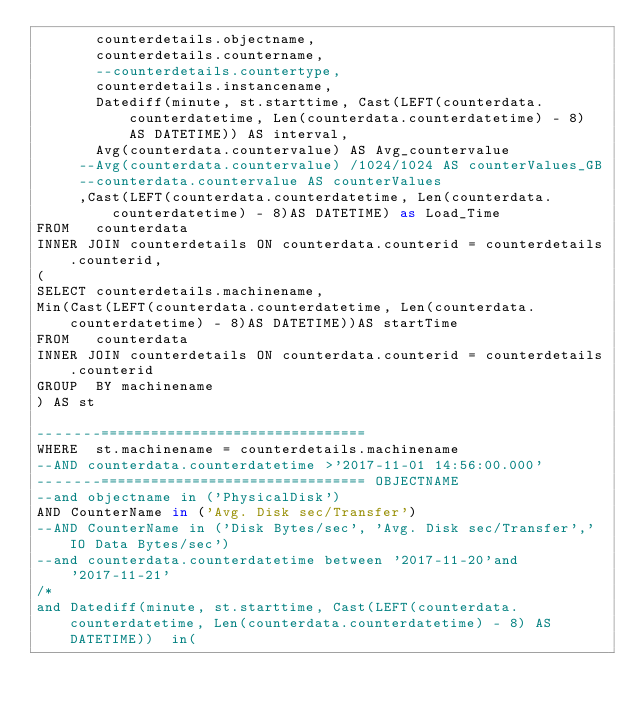<code> <loc_0><loc_0><loc_500><loc_500><_SQL_>       counterdetails.objectname,
       counterdetails.countername,
       --counterdetails.countertype,
       counterdetails.instancename,
       Datediff(minute, st.starttime, Cast(LEFT(counterdata.counterdatetime, Len(counterdata.counterdatetime) - 8) AS DATETIME)) AS interval,
       Avg(counterdata.countervalue) AS Avg_countervalue
	   --Avg(counterdata.countervalue) /1024/1024 AS counterValues_GB
	   --counterdata.countervalue AS counterValues
	   ,Cast(LEFT(counterdata.counterdatetime, Len(counterdata.counterdatetime) - 8)AS DATETIME) as Load_Time
FROM   counterdata
INNER JOIN counterdetails ON counterdata.counterid = counterdetails.counterid,
(
SELECT counterdetails.machinename,
Min(Cast(LEFT(counterdata.counterdatetime, Len(counterdata.counterdatetime) - 8)AS DATETIME))AS startTime
FROM   counterdata
INNER JOIN counterdetails ON counterdata.counterid = counterdetails.counterid
GROUP  BY machinename
) AS st

-------================================
WHERE  st.machinename = counterdetails.machinename
--AND counterdata.counterdatetime >'2017-11-01 14:56:00.000'
-------================================ OBJECTNAME
--and objectname in ('PhysicalDisk')
AND CounterName in ('Avg. Disk sec/Transfer')
--AND CounterName in ('Disk Bytes/sec', 'Avg. Disk sec/Transfer','IO Data Bytes/sec')
--and counterdata.counterdatetime between '2017-11-20'and'2017-11-21'
/*
and Datediff(minute, st.starttime, Cast(LEFT(counterdata.counterdatetime, Len(counterdata.counterdatetime) - 8) AS DATETIME))  in(</code> 